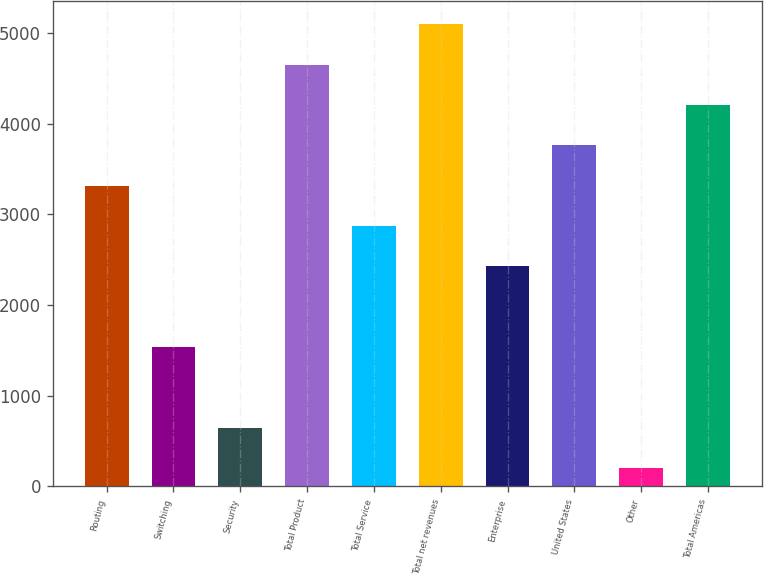Convert chart. <chart><loc_0><loc_0><loc_500><loc_500><bar_chart><fcel>Routing<fcel>Switching<fcel>Security<fcel>Total Product<fcel>Total Service<fcel>Total net revenues<fcel>Enterprise<fcel>United States<fcel>Other<fcel>Total Americas<nl><fcel>3313.88<fcel>1535.72<fcel>646.64<fcel>4647.5<fcel>2869.34<fcel>5092.04<fcel>2424.8<fcel>3758.42<fcel>202.1<fcel>4202.96<nl></chart> 